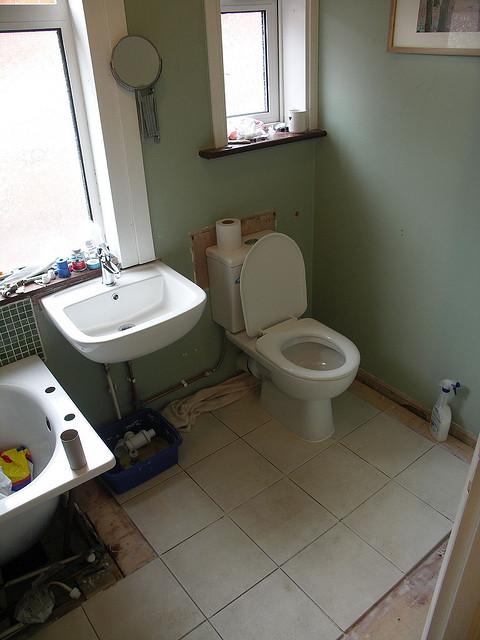Is the sink square?
Short answer required. Yes. Is the floor finished?
Be succinct. No. Is the toilet round or oval?
Answer briefly. Oval. Are there blinds on the windows?
Short answer required. No. 